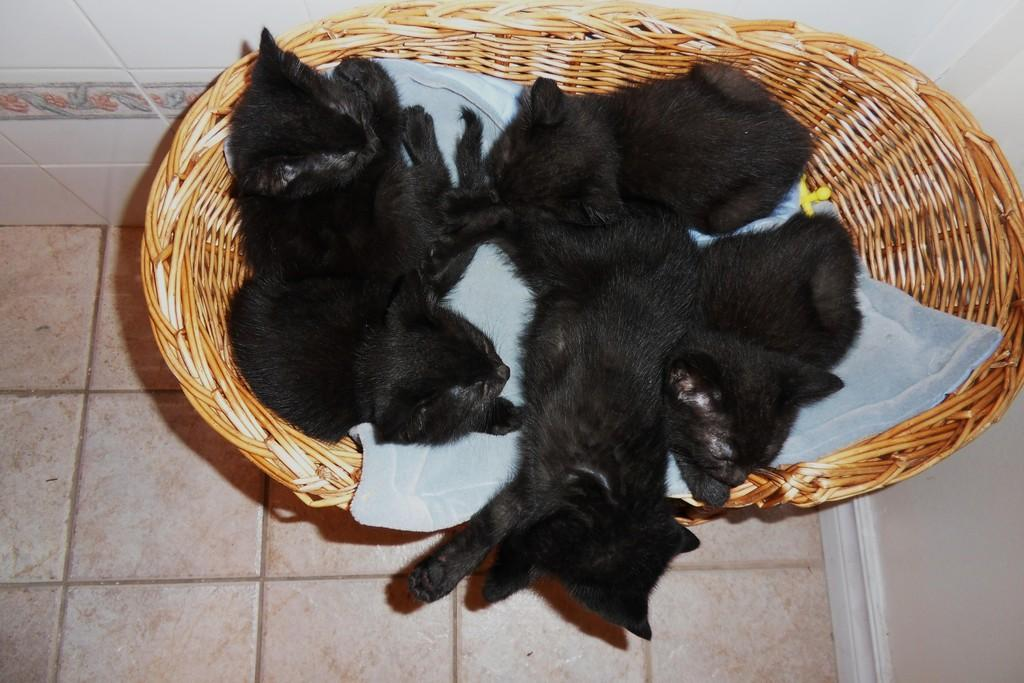What type of animals are in the image? There are kittens in the image. What are the kittens doing in the image? The kittens are sleeping. Where are the kittens located in the image? The kittens are in a basket. What is the position of the basket in the image? The basket is placed on the floor. What can be seen in the background of the image? There is a wall visible in the background of the image. What type of oranges can be seen in the image? There are no oranges present in the image; it features kittens sleeping in a basket. How many times do the kittens shake their tails in the image? The kittens are sleeping in the image, so there is no tail-shaking activity to count. 